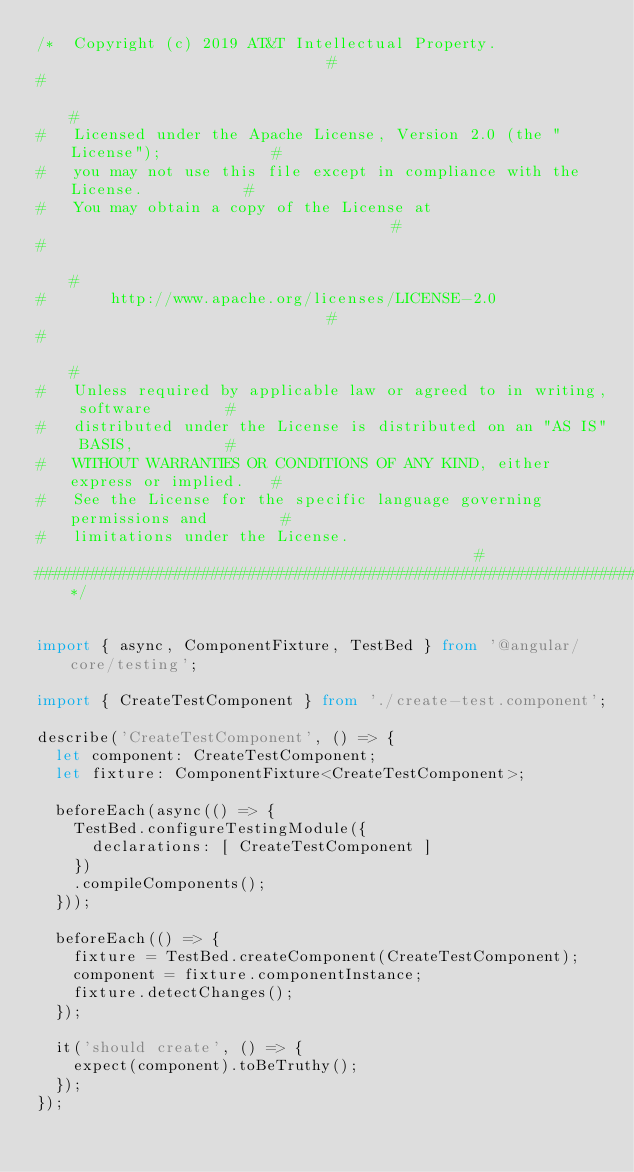Convert code to text. <code><loc_0><loc_0><loc_500><loc_500><_TypeScript_>/*  Copyright (c) 2019 AT&T Intellectual Property.                             #
#                                                                              #
#   Licensed under the Apache License, Version 2.0 (the "License");            #
#   you may not use this file except in compliance with the License.           #
#   You may obtain a copy of the License at                                    #
#                                                                              #
#       http://www.apache.org/licenses/LICENSE-2.0                             #
#                                                                              #
#   Unless required by applicable law or agreed to in writing, software        #
#   distributed under the License is distributed on an "AS IS" BASIS,          #
#   WITHOUT WARRANTIES OR CONDITIONS OF ANY KIND, either express or implied.   #
#   See the License for the specific language governing permissions and        #
#   limitations under the License.                                             #
##############################################################################*/


import { async, ComponentFixture, TestBed } from '@angular/core/testing';

import { CreateTestComponent } from './create-test.component';

describe('CreateTestComponent', () => {
  let component: CreateTestComponent;
  let fixture: ComponentFixture<CreateTestComponent>;

  beforeEach(async(() => {
    TestBed.configureTestingModule({
      declarations: [ CreateTestComponent ]
    })
    .compileComponents();
  }));

  beforeEach(() => {
    fixture = TestBed.createComponent(CreateTestComponent);
    component = fixture.componentInstance;
    fixture.detectChanges();
  });

  it('should create', () => {
    expect(component).toBeTruthy();
  });
});
</code> 